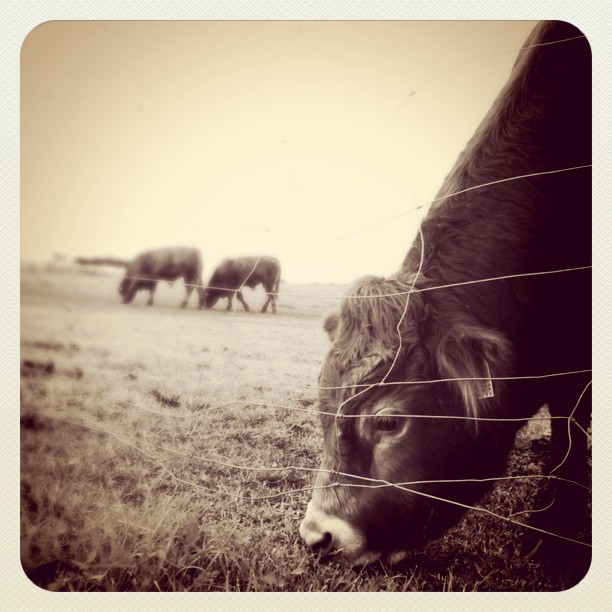What are the animals in the background doing? The animals in the background appear to be grazing in the field, a common behavior for cattle in a pasture. 